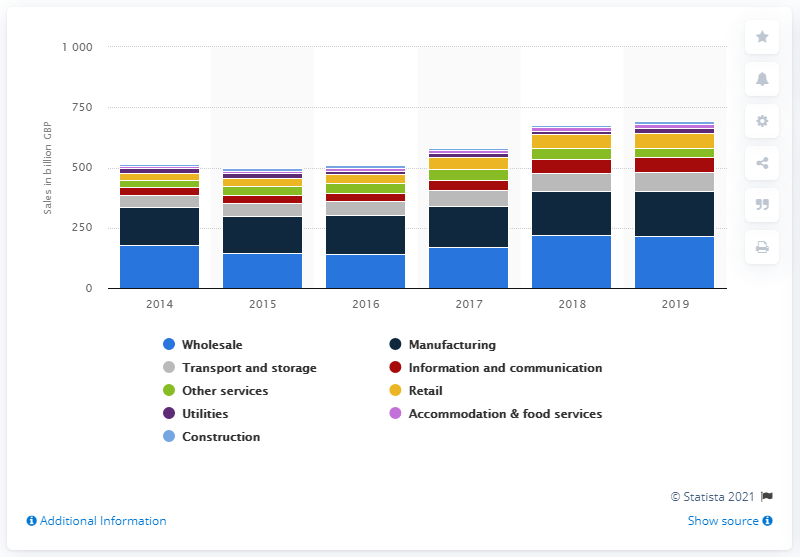Specify some key components in this picture. In 2019, retail sales generated approximately $60.5 billion in revenue. In 2019, the wholesale sector generated $214.7 million in sales. 